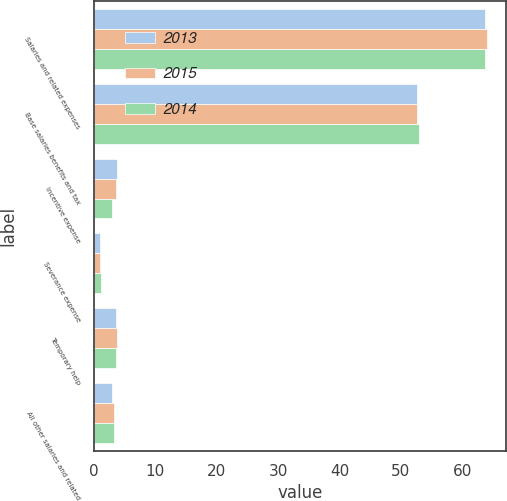Convert chart to OTSL. <chart><loc_0><loc_0><loc_500><loc_500><stacked_bar_chart><ecel><fcel>Salaries and related expenses<fcel>Base salaries benefits and tax<fcel>Incentive expense<fcel>Severance expense<fcel>Temporary help<fcel>All other salaries and related<nl><fcel>2013<fcel>63.8<fcel>52.7<fcel>3.7<fcel>0.9<fcel>3.6<fcel>2.9<nl><fcel>2015<fcel>64<fcel>52.6<fcel>3.5<fcel>0.9<fcel>3.8<fcel>3.2<nl><fcel>2014<fcel>63.8<fcel>52.9<fcel>3<fcel>1.1<fcel>3.6<fcel>3.2<nl></chart> 